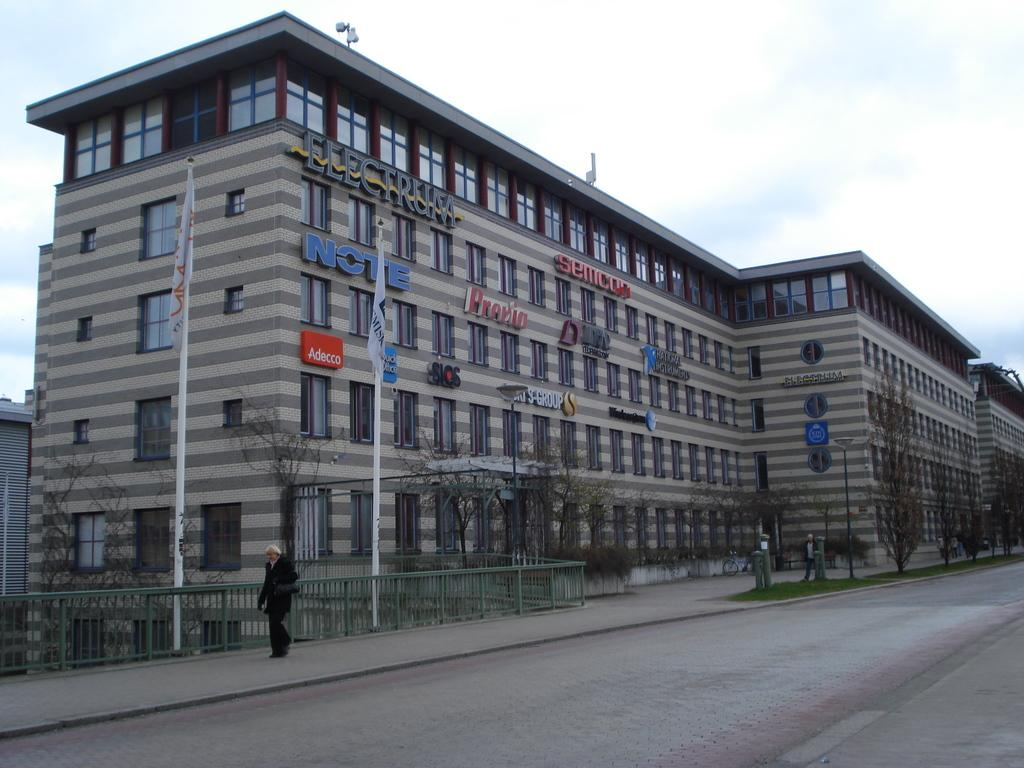What structures are located on the left side of the image? There are buildings on the left side of the image. What type of vegetation can be seen in the image? There are trees in the image. What objects are present in the image that are related to flags? There are flags in the image. What type of poles can be seen in the image? There are poles in the image. What type of ground surface is visible in the image? There is grass in the image. What is the man at the bottom of the image doing? The man is walking at the bottom of the image. What is visible at the top of the image? The sky is visible at the top of the image. What can be seen in the sky? There are clouds in the sky. Is the man walking on quicksand in the image? There is no quicksand present in the image; the man is walking on grass. Can you see a frog hopping in the image? There is no frog present in the image. 